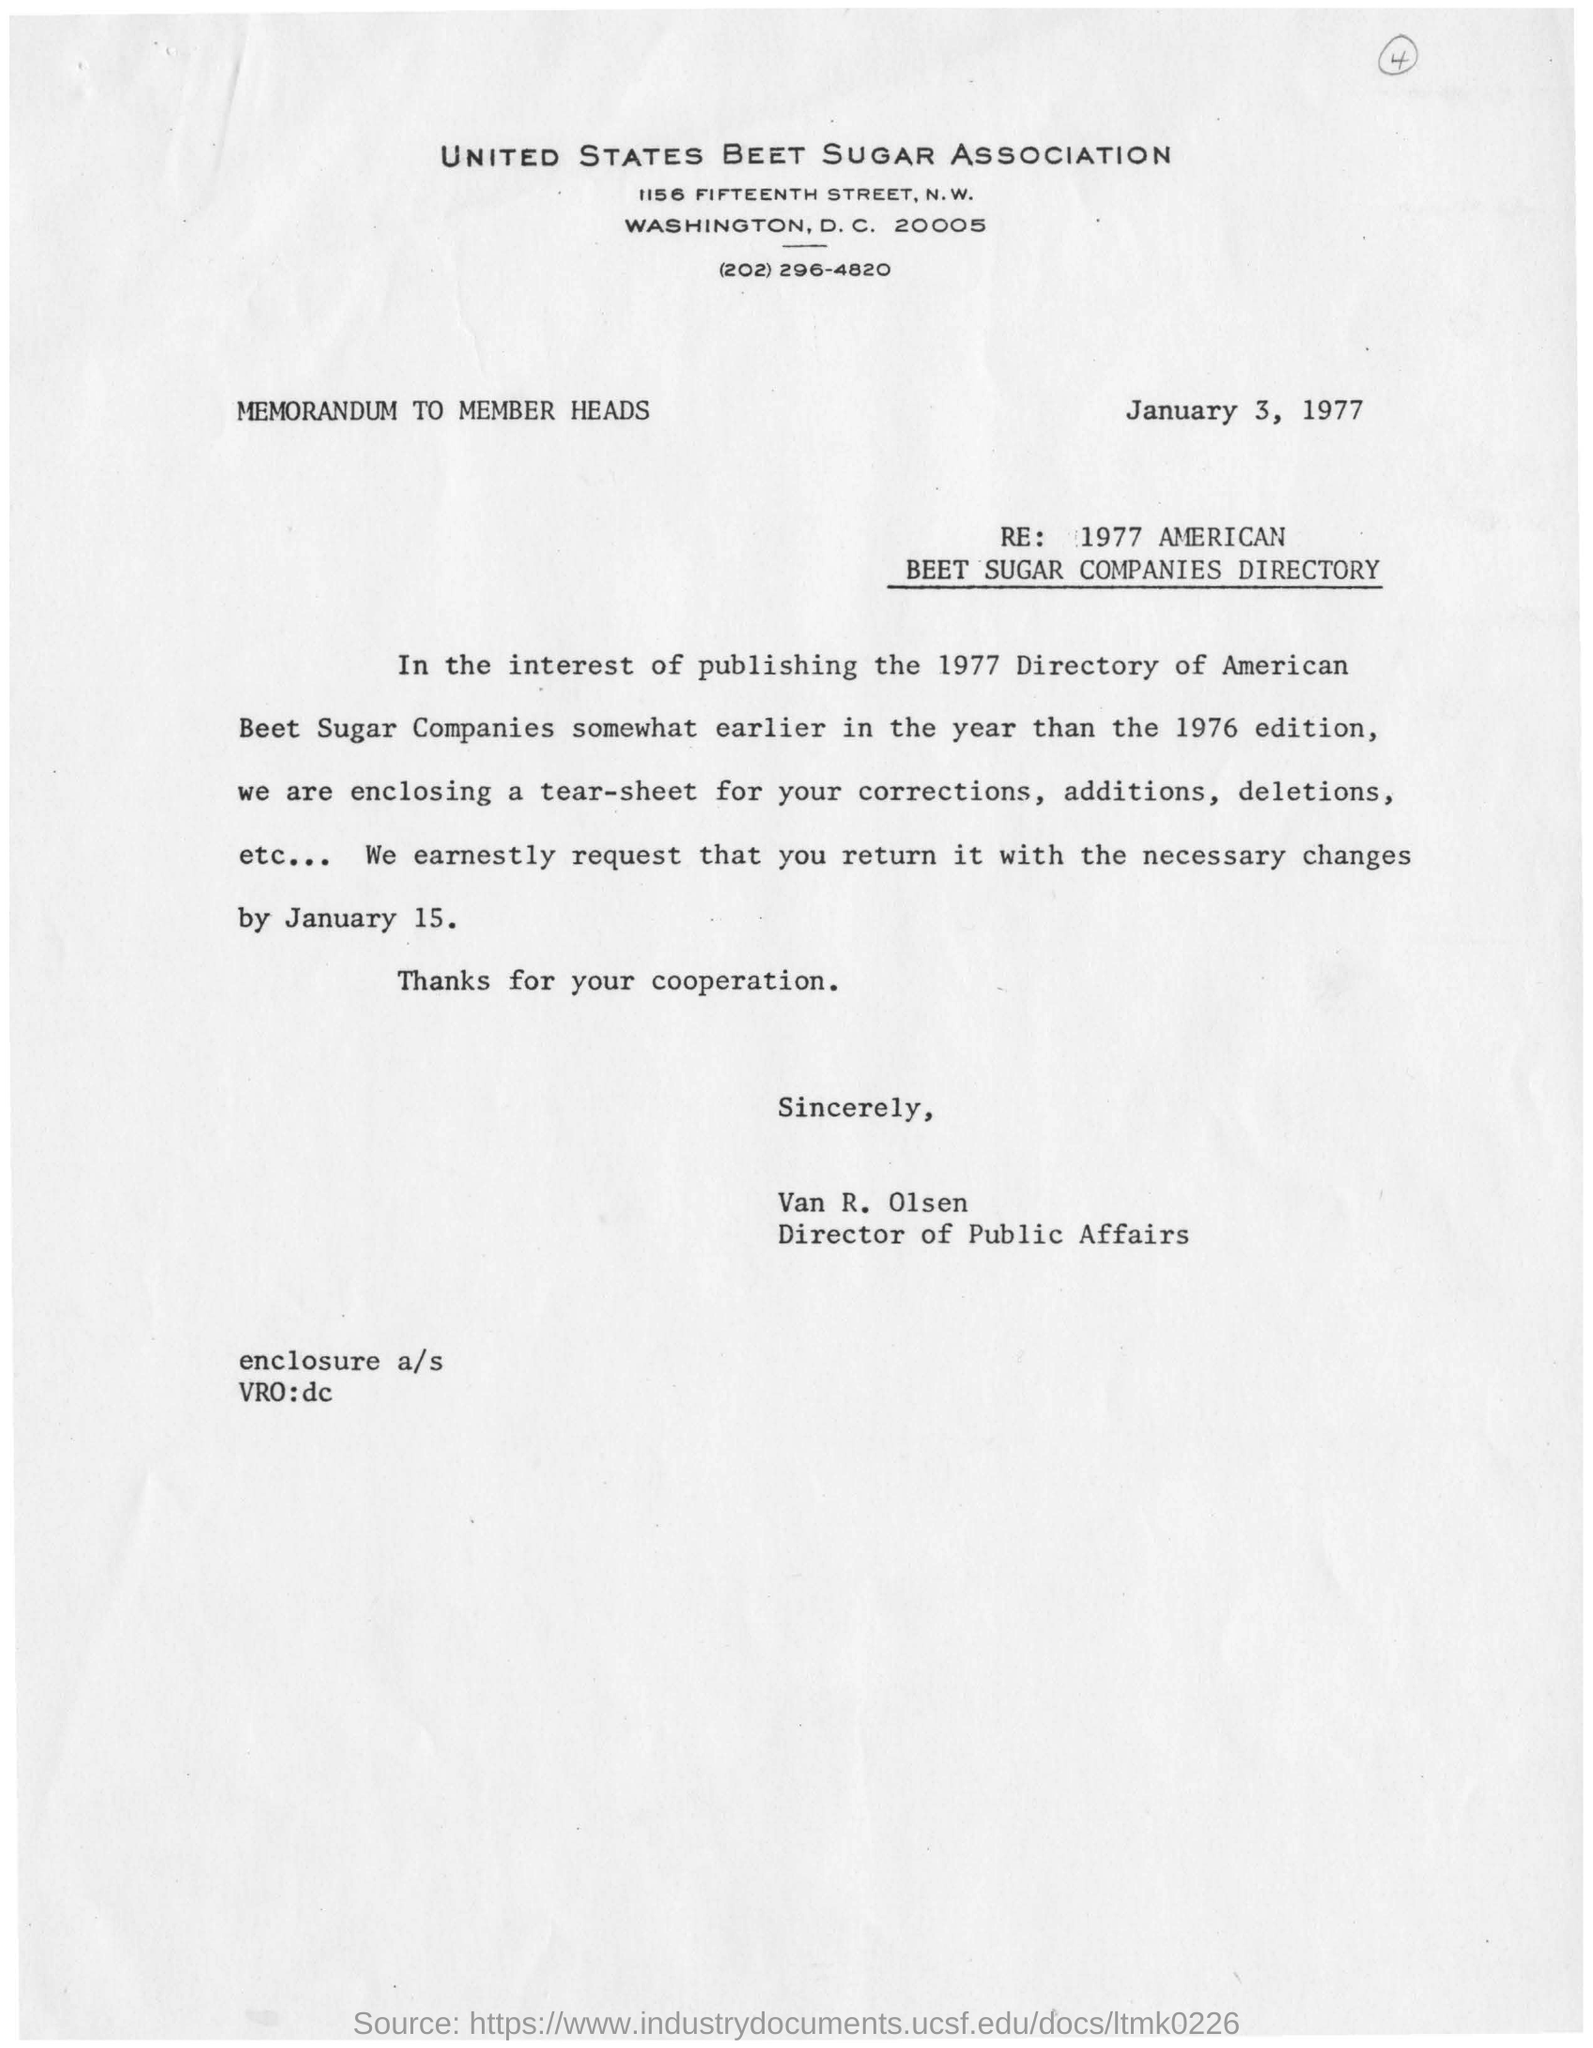Who is the director of the Public affairs?
Your response must be concise. VAN R. OLSEN. When is the letter dated?
Your answer should be compact. JANUARY 3, 1977. What is the purpose of the letter?
Provide a succinct answer. Enclosing a tear sheet  for corrections, additions, deletions etc. In which year is the directory likely to publish?
Provide a succinct answer. 1977. 